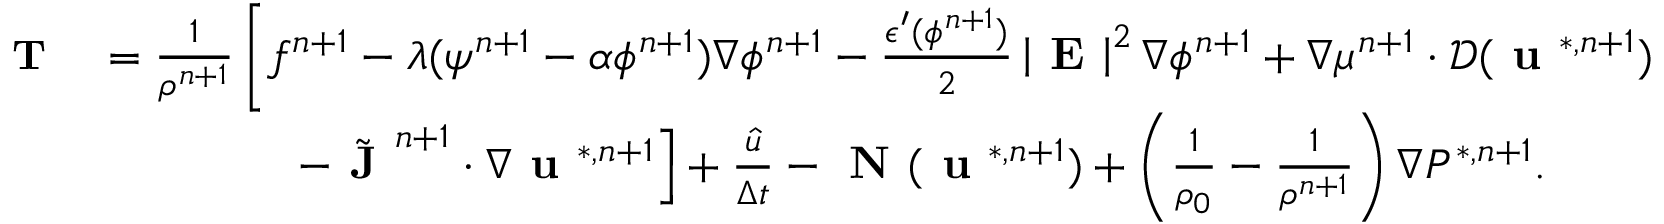<formula> <loc_0><loc_0><loc_500><loc_500>\begin{array} { r l } { T } & { = \frac { 1 } { \rho ^ { n + 1 } } \left [ f ^ { n + 1 } - \lambda ( \psi ^ { n + 1 } - \alpha \phi ^ { n + 1 } ) \nabla \phi ^ { n + 1 } - \frac { \epsilon ^ { \prime } ( \phi ^ { n + 1 } ) } { 2 } \left | E \right | ^ { 2 } \nabla \phi ^ { n + 1 } + \nabla \mu ^ { n + 1 } \cdot \mathcal { D } ( u ^ { * , n + 1 } ) } \\ & { \quad - \tilde { J } ^ { n + 1 } \cdot \nabla u ^ { * , n + 1 } \right ] + \frac { \hat { u } } { \Delta t } - N ( u ^ { * , n + 1 } ) + \left ( \frac { 1 } { \rho _ { 0 } } - \frac { 1 } { \rho ^ { n + 1 } } \right ) \nabla P ^ { * , n + 1 } . } \end{array}</formula> 